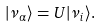Convert formula to latex. <formula><loc_0><loc_0><loc_500><loc_500>| \nu _ { \alpha } \rangle = U | \nu _ { i } \rangle .</formula> 